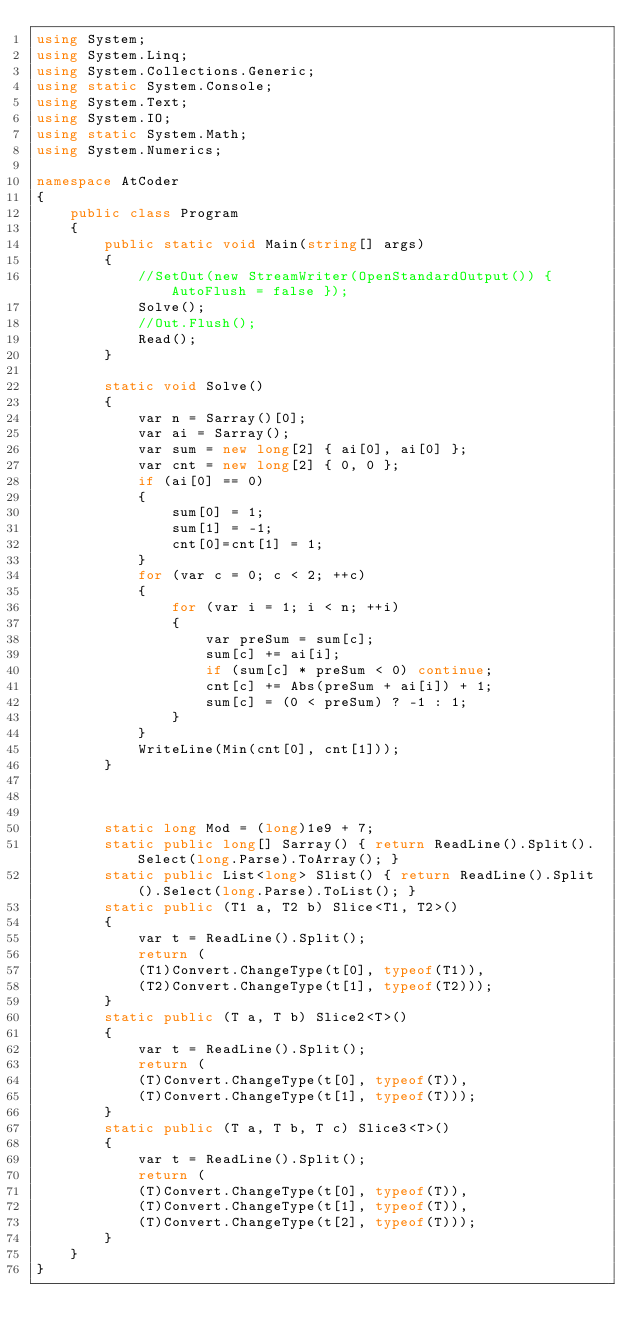<code> <loc_0><loc_0><loc_500><loc_500><_C#_>using System;
using System.Linq;
using System.Collections.Generic;
using static System.Console;
using System.Text;
using System.IO;
using static System.Math;
using System.Numerics;

namespace AtCoder
{
    public class Program
    {
        public static void Main(string[] args)
        {
            //SetOut(new StreamWriter(OpenStandardOutput()) { AutoFlush = false });
            Solve();
            //Out.Flush();
            Read();
        }

        static void Solve()
        {
            var n = Sarray()[0];
            var ai = Sarray();
            var sum = new long[2] { ai[0], ai[0] };
            var cnt = new long[2] { 0, 0 };
            if (ai[0] == 0)
            {
                sum[0] = 1;
                sum[1] = -1;
                cnt[0]=cnt[1] = 1;
            }
            for (var c = 0; c < 2; ++c)
            {
                for (var i = 1; i < n; ++i)
                {
                    var preSum = sum[c];
                    sum[c] += ai[i];
                    if (sum[c] * preSum < 0) continue;
                    cnt[c] += Abs(preSum + ai[i]) + 1;
                    sum[c] = (0 < preSum) ? -1 : 1;
                }
            }
            WriteLine(Min(cnt[0], cnt[1]));
        }
        


        static long Mod = (long)1e9 + 7;
        static public long[] Sarray() { return ReadLine().Split().Select(long.Parse).ToArray(); }
        static public List<long> Slist() { return ReadLine().Split().Select(long.Parse).ToList(); }
        static public (T1 a, T2 b) Slice<T1, T2>()
        {
            var t = ReadLine().Split();
            return (
            (T1)Convert.ChangeType(t[0], typeof(T1)),
            (T2)Convert.ChangeType(t[1], typeof(T2)));
        }
        static public (T a, T b) Slice2<T>()
        {
            var t = ReadLine().Split();
            return (
            (T)Convert.ChangeType(t[0], typeof(T)),
            (T)Convert.ChangeType(t[1], typeof(T)));
        }
        static public (T a, T b, T c) Slice3<T>()
        {
            var t = ReadLine().Split();
            return (
            (T)Convert.ChangeType(t[0], typeof(T)),
            (T)Convert.ChangeType(t[1], typeof(T)),
            (T)Convert.ChangeType(t[2], typeof(T)));
        }
    }
}</code> 